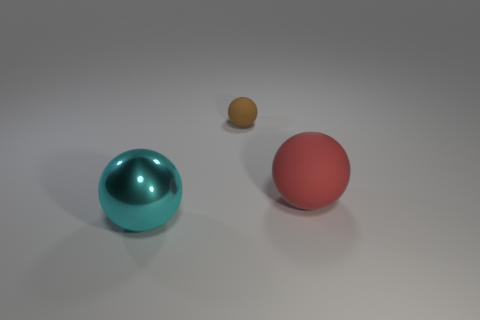There is a cyan thing that is the same shape as the small brown matte object; what size is it?
Make the answer very short. Large. Are there more rubber objects in front of the brown thing than green metallic cubes?
Offer a very short reply. Yes. Is the large red sphere made of the same material as the big cyan object?
Your answer should be compact. No. What number of objects are either rubber balls behind the red ball or things behind the big red thing?
Provide a short and direct response. 1. What is the color of the small object that is the same shape as the big red object?
Ensure brevity in your answer.  Brown. What number of objects are spheres on the left side of the tiny brown rubber object or tiny purple matte cylinders?
Provide a short and direct response. 1. What color is the rubber sphere that is behind the large ball behind the thing on the left side of the small ball?
Your response must be concise. Brown. There is a big sphere that is the same material as the small brown object; what color is it?
Your answer should be very brief. Red. What number of other balls are the same material as the brown sphere?
Make the answer very short. 1. There is a sphere that is to the right of the brown sphere; does it have the same size as the large cyan metal object?
Keep it short and to the point. Yes. 